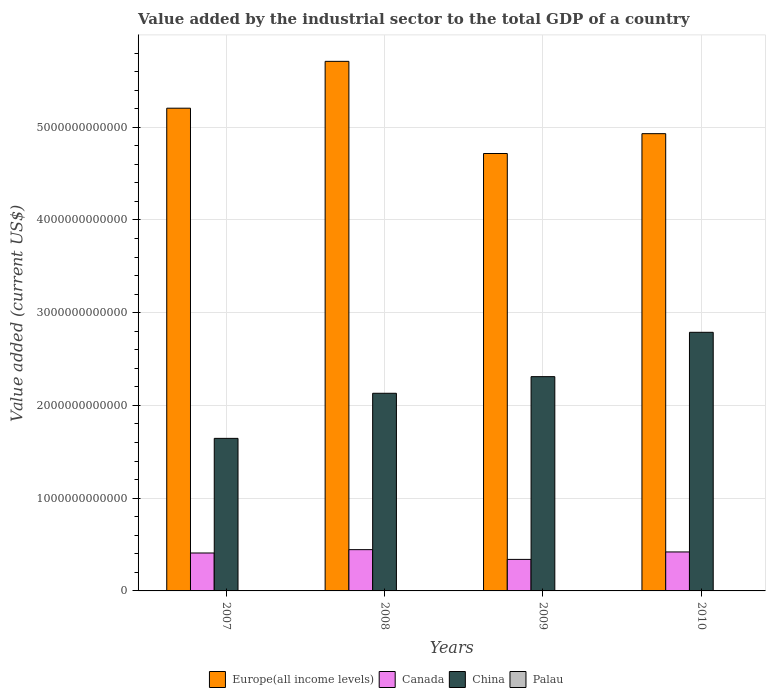How many different coloured bars are there?
Provide a short and direct response. 4. How many groups of bars are there?
Provide a short and direct response. 4. Are the number of bars per tick equal to the number of legend labels?
Provide a short and direct response. Yes. Are the number of bars on each tick of the X-axis equal?
Provide a short and direct response. Yes. How many bars are there on the 2nd tick from the left?
Give a very brief answer. 4. What is the label of the 2nd group of bars from the left?
Your answer should be compact. 2008. In how many cases, is the number of bars for a given year not equal to the number of legend labels?
Ensure brevity in your answer.  0. What is the value added by the industrial sector to the total GDP in China in 2009?
Your answer should be very brief. 2.31e+12. Across all years, what is the maximum value added by the industrial sector to the total GDP in Canada?
Make the answer very short. 4.45e+11. Across all years, what is the minimum value added by the industrial sector to the total GDP in China?
Make the answer very short. 1.65e+12. What is the total value added by the industrial sector to the total GDP in Palau in the graph?
Provide a succinct answer. 7.32e+07. What is the difference between the value added by the industrial sector to the total GDP in Europe(all income levels) in 2007 and that in 2010?
Provide a short and direct response. 2.75e+11. What is the difference between the value added by the industrial sector to the total GDP in Canada in 2010 and the value added by the industrial sector to the total GDP in Palau in 2009?
Give a very brief answer. 4.20e+11. What is the average value added by the industrial sector to the total GDP in Europe(all income levels) per year?
Your answer should be compact. 5.14e+12. In the year 2008, what is the difference between the value added by the industrial sector to the total GDP in China and value added by the industrial sector to the total GDP in Europe(all income levels)?
Your answer should be very brief. -3.58e+12. In how many years, is the value added by the industrial sector to the total GDP in Canada greater than 4600000000000 US$?
Offer a very short reply. 0. What is the ratio of the value added by the industrial sector to the total GDP in Europe(all income levels) in 2007 to that in 2009?
Give a very brief answer. 1.1. Is the difference between the value added by the industrial sector to the total GDP in China in 2007 and 2009 greater than the difference between the value added by the industrial sector to the total GDP in Europe(all income levels) in 2007 and 2009?
Your answer should be compact. No. What is the difference between the highest and the second highest value added by the industrial sector to the total GDP in Europe(all income levels)?
Your answer should be compact. 5.05e+11. What is the difference between the highest and the lowest value added by the industrial sector to the total GDP in Europe(all income levels)?
Make the answer very short. 9.94e+11. Is it the case that in every year, the sum of the value added by the industrial sector to the total GDP in China and value added by the industrial sector to the total GDP in Canada is greater than the sum of value added by the industrial sector to the total GDP in Europe(all income levels) and value added by the industrial sector to the total GDP in Palau?
Offer a terse response. No. What does the 2nd bar from the left in 2007 represents?
Offer a terse response. Canada. What does the 3rd bar from the right in 2007 represents?
Give a very brief answer. Canada. Is it the case that in every year, the sum of the value added by the industrial sector to the total GDP in Europe(all income levels) and value added by the industrial sector to the total GDP in Canada is greater than the value added by the industrial sector to the total GDP in China?
Provide a succinct answer. Yes. Are all the bars in the graph horizontal?
Your answer should be compact. No. What is the difference between two consecutive major ticks on the Y-axis?
Your answer should be very brief. 1.00e+12. Does the graph contain any zero values?
Offer a terse response. No. Does the graph contain grids?
Provide a succinct answer. Yes. How many legend labels are there?
Your response must be concise. 4. What is the title of the graph?
Keep it short and to the point. Value added by the industrial sector to the total GDP of a country. What is the label or title of the Y-axis?
Offer a terse response. Value added (current US$). What is the Value added (current US$) in Europe(all income levels) in 2007?
Offer a very short reply. 5.21e+12. What is the Value added (current US$) in Canada in 2007?
Offer a very short reply. 4.09e+11. What is the Value added (current US$) in China in 2007?
Provide a short and direct response. 1.65e+12. What is the Value added (current US$) of Palau in 2007?
Give a very brief answer. 2.17e+07. What is the Value added (current US$) in Europe(all income levels) in 2008?
Make the answer very short. 5.71e+12. What is the Value added (current US$) of Canada in 2008?
Provide a succinct answer. 4.45e+11. What is the Value added (current US$) in China in 2008?
Your answer should be compact. 2.13e+12. What is the Value added (current US$) of Palau in 2008?
Your response must be concise. 1.67e+07. What is the Value added (current US$) of Europe(all income levels) in 2009?
Make the answer very short. 4.72e+12. What is the Value added (current US$) of Canada in 2009?
Give a very brief answer. 3.40e+11. What is the Value added (current US$) in China in 2009?
Your answer should be compact. 2.31e+12. What is the Value added (current US$) in Palau in 2009?
Your answer should be compact. 1.66e+07. What is the Value added (current US$) of Europe(all income levels) in 2010?
Offer a very short reply. 4.93e+12. What is the Value added (current US$) of Canada in 2010?
Ensure brevity in your answer.  4.20e+11. What is the Value added (current US$) in China in 2010?
Your answer should be compact. 2.79e+12. What is the Value added (current US$) of Palau in 2010?
Give a very brief answer. 1.82e+07. Across all years, what is the maximum Value added (current US$) of Europe(all income levels)?
Ensure brevity in your answer.  5.71e+12. Across all years, what is the maximum Value added (current US$) in Canada?
Give a very brief answer. 4.45e+11. Across all years, what is the maximum Value added (current US$) of China?
Your answer should be compact. 2.79e+12. Across all years, what is the maximum Value added (current US$) in Palau?
Your answer should be very brief. 2.17e+07. Across all years, what is the minimum Value added (current US$) of Europe(all income levels)?
Provide a short and direct response. 4.72e+12. Across all years, what is the minimum Value added (current US$) of Canada?
Make the answer very short. 3.40e+11. Across all years, what is the minimum Value added (current US$) in China?
Offer a very short reply. 1.65e+12. Across all years, what is the minimum Value added (current US$) of Palau?
Keep it short and to the point. 1.66e+07. What is the total Value added (current US$) in Europe(all income levels) in the graph?
Ensure brevity in your answer.  2.06e+13. What is the total Value added (current US$) in Canada in the graph?
Make the answer very short. 1.61e+12. What is the total Value added (current US$) of China in the graph?
Your answer should be compact. 8.88e+12. What is the total Value added (current US$) of Palau in the graph?
Offer a very short reply. 7.32e+07. What is the difference between the Value added (current US$) in Europe(all income levels) in 2007 and that in 2008?
Keep it short and to the point. -5.05e+11. What is the difference between the Value added (current US$) in Canada in 2007 and that in 2008?
Make the answer very short. -3.60e+1. What is the difference between the Value added (current US$) of China in 2007 and that in 2008?
Your answer should be compact. -4.86e+11. What is the difference between the Value added (current US$) in Palau in 2007 and that in 2008?
Keep it short and to the point. 5.05e+06. What is the difference between the Value added (current US$) in Europe(all income levels) in 2007 and that in 2009?
Provide a short and direct response. 4.89e+11. What is the difference between the Value added (current US$) in Canada in 2007 and that in 2009?
Offer a terse response. 6.92e+1. What is the difference between the Value added (current US$) of China in 2007 and that in 2009?
Provide a short and direct response. -6.66e+11. What is the difference between the Value added (current US$) in Palau in 2007 and that in 2009?
Your answer should be compact. 5.14e+06. What is the difference between the Value added (current US$) of Europe(all income levels) in 2007 and that in 2010?
Your answer should be very brief. 2.75e+11. What is the difference between the Value added (current US$) in Canada in 2007 and that in 2010?
Your answer should be compact. -1.13e+1. What is the difference between the Value added (current US$) of China in 2007 and that in 2010?
Offer a very short reply. -1.14e+12. What is the difference between the Value added (current US$) in Palau in 2007 and that in 2010?
Your answer should be compact. 3.50e+06. What is the difference between the Value added (current US$) of Europe(all income levels) in 2008 and that in 2009?
Your answer should be compact. 9.94e+11. What is the difference between the Value added (current US$) in Canada in 2008 and that in 2009?
Offer a very short reply. 1.05e+11. What is the difference between the Value added (current US$) of China in 2008 and that in 2009?
Offer a very short reply. -1.79e+11. What is the difference between the Value added (current US$) in Palau in 2008 and that in 2009?
Give a very brief answer. 8.72e+04. What is the difference between the Value added (current US$) of Europe(all income levels) in 2008 and that in 2010?
Keep it short and to the point. 7.80e+11. What is the difference between the Value added (current US$) of Canada in 2008 and that in 2010?
Make the answer very short. 2.47e+1. What is the difference between the Value added (current US$) in China in 2008 and that in 2010?
Make the answer very short. -6.57e+11. What is the difference between the Value added (current US$) in Palau in 2008 and that in 2010?
Keep it short and to the point. -1.55e+06. What is the difference between the Value added (current US$) of Europe(all income levels) in 2009 and that in 2010?
Your answer should be very brief. -2.14e+11. What is the difference between the Value added (current US$) of Canada in 2009 and that in 2010?
Keep it short and to the point. -8.05e+1. What is the difference between the Value added (current US$) of China in 2009 and that in 2010?
Make the answer very short. -4.78e+11. What is the difference between the Value added (current US$) in Palau in 2009 and that in 2010?
Offer a terse response. -1.64e+06. What is the difference between the Value added (current US$) of Europe(all income levels) in 2007 and the Value added (current US$) of Canada in 2008?
Your response must be concise. 4.76e+12. What is the difference between the Value added (current US$) of Europe(all income levels) in 2007 and the Value added (current US$) of China in 2008?
Your response must be concise. 3.07e+12. What is the difference between the Value added (current US$) in Europe(all income levels) in 2007 and the Value added (current US$) in Palau in 2008?
Keep it short and to the point. 5.21e+12. What is the difference between the Value added (current US$) of Canada in 2007 and the Value added (current US$) of China in 2008?
Offer a terse response. -1.72e+12. What is the difference between the Value added (current US$) in Canada in 2007 and the Value added (current US$) in Palau in 2008?
Give a very brief answer. 4.09e+11. What is the difference between the Value added (current US$) of China in 2007 and the Value added (current US$) of Palau in 2008?
Your response must be concise. 1.65e+12. What is the difference between the Value added (current US$) of Europe(all income levels) in 2007 and the Value added (current US$) of Canada in 2009?
Offer a very short reply. 4.87e+12. What is the difference between the Value added (current US$) of Europe(all income levels) in 2007 and the Value added (current US$) of China in 2009?
Your response must be concise. 2.89e+12. What is the difference between the Value added (current US$) of Europe(all income levels) in 2007 and the Value added (current US$) of Palau in 2009?
Your answer should be very brief. 5.21e+12. What is the difference between the Value added (current US$) in Canada in 2007 and the Value added (current US$) in China in 2009?
Give a very brief answer. -1.90e+12. What is the difference between the Value added (current US$) of Canada in 2007 and the Value added (current US$) of Palau in 2009?
Make the answer very short. 4.09e+11. What is the difference between the Value added (current US$) in China in 2007 and the Value added (current US$) in Palau in 2009?
Provide a succinct answer. 1.65e+12. What is the difference between the Value added (current US$) in Europe(all income levels) in 2007 and the Value added (current US$) in Canada in 2010?
Offer a terse response. 4.79e+12. What is the difference between the Value added (current US$) of Europe(all income levels) in 2007 and the Value added (current US$) of China in 2010?
Offer a very short reply. 2.42e+12. What is the difference between the Value added (current US$) of Europe(all income levels) in 2007 and the Value added (current US$) of Palau in 2010?
Your answer should be very brief. 5.21e+12. What is the difference between the Value added (current US$) of Canada in 2007 and the Value added (current US$) of China in 2010?
Provide a short and direct response. -2.38e+12. What is the difference between the Value added (current US$) in Canada in 2007 and the Value added (current US$) in Palau in 2010?
Keep it short and to the point. 4.09e+11. What is the difference between the Value added (current US$) in China in 2007 and the Value added (current US$) in Palau in 2010?
Your answer should be compact. 1.65e+12. What is the difference between the Value added (current US$) of Europe(all income levels) in 2008 and the Value added (current US$) of Canada in 2009?
Provide a short and direct response. 5.37e+12. What is the difference between the Value added (current US$) in Europe(all income levels) in 2008 and the Value added (current US$) in China in 2009?
Provide a short and direct response. 3.40e+12. What is the difference between the Value added (current US$) of Europe(all income levels) in 2008 and the Value added (current US$) of Palau in 2009?
Give a very brief answer. 5.71e+12. What is the difference between the Value added (current US$) of Canada in 2008 and the Value added (current US$) of China in 2009?
Provide a short and direct response. -1.87e+12. What is the difference between the Value added (current US$) of Canada in 2008 and the Value added (current US$) of Palau in 2009?
Give a very brief answer. 4.45e+11. What is the difference between the Value added (current US$) of China in 2008 and the Value added (current US$) of Palau in 2009?
Provide a short and direct response. 2.13e+12. What is the difference between the Value added (current US$) in Europe(all income levels) in 2008 and the Value added (current US$) in Canada in 2010?
Your answer should be compact. 5.29e+12. What is the difference between the Value added (current US$) of Europe(all income levels) in 2008 and the Value added (current US$) of China in 2010?
Your response must be concise. 2.92e+12. What is the difference between the Value added (current US$) in Europe(all income levels) in 2008 and the Value added (current US$) in Palau in 2010?
Provide a short and direct response. 5.71e+12. What is the difference between the Value added (current US$) of Canada in 2008 and the Value added (current US$) of China in 2010?
Offer a terse response. -2.34e+12. What is the difference between the Value added (current US$) in Canada in 2008 and the Value added (current US$) in Palau in 2010?
Make the answer very short. 4.45e+11. What is the difference between the Value added (current US$) in China in 2008 and the Value added (current US$) in Palau in 2010?
Keep it short and to the point. 2.13e+12. What is the difference between the Value added (current US$) in Europe(all income levels) in 2009 and the Value added (current US$) in Canada in 2010?
Offer a very short reply. 4.30e+12. What is the difference between the Value added (current US$) of Europe(all income levels) in 2009 and the Value added (current US$) of China in 2010?
Offer a very short reply. 1.93e+12. What is the difference between the Value added (current US$) in Europe(all income levels) in 2009 and the Value added (current US$) in Palau in 2010?
Ensure brevity in your answer.  4.72e+12. What is the difference between the Value added (current US$) in Canada in 2009 and the Value added (current US$) in China in 2010?
Offer a very short reply. -2.45e+12. What is the difference between the Value added (current US$) of Canada in 2009 and the Value added (current US$) of Palau in 2010?
Your answer should be compact. 3.40e+11. What is the difference between the Value added (current US$) in China in 2009 and the Value added (current US$) in Palau in 2010?
Offer a terse response. 2.31e+12. What is the average Value added (current US$) in Europe(all income levels) per year?
Provide a short and direct response. 5.14e+12. What is the average Value added (current US$) in Canada per year?
Ensure brevity in your answer.  4.04e+11. What is the average Value added (current US$) of China per year?
Provide a short and direct response. 2.22e+12. What is the average Value added (current US$) in Palau per year?
Offer a terse response. 1.83e+07. In the year 2007, what is the difference between the Value added (current US$) of Europe(all income levels) and Value added (current US$) of Canada?
Keep it short and to the point. 4.80e+12. In the year 2007, what is the difference between the Value added (current US$) of Europe(all income levels) and Value added (current US$) of China?
Your answer should be compact. 3.56e+12. In the year 2007, what is the difference between the Value added (current US$) of Europe(all income levels) and Value added (current US$) of Palau?
Your answer should be compact. 5.21e+12. In the year 2007, what is the difference between the Value added (current US$) of Canada and Value added (current US$) of China?
Keep it short and to the point. -1.24e+12. In the year 2007, what is the difference between the Value added (current US$) of Canada and Value added (current US$) of Palau?
Provide a short and direct response. 4.09e+11. In the year 2007, what is the difference between the Value added (current US$) of China and Value added (current US$) of Palau?
Ensure brevity in your answer.  1.65e+12. In the year 2008, what is the difference between the Value added (current US$) in Europe(all income levels) and Value added (current US$) in Canada?
Offer a very short reply. 5.27e+12. In the year 2008, what is the difference between the Value added (current US$) in Europe(all income levels) and Value added (current US$) in China?
Provide a short and direct response. 3.58e+12. In the year 2008, what is the difference between the Value added (current US$) in Europe(all income levels) and Value added (current US$) in Palau?
Ensure brevity in your answer.  5.71e+12. In the year 2008, what is the difference between the Value added (current US$) in Canada and Value added (current US$) in China?
Your response must be concise. -1.69e+12. In the year 2008, what is the difference between the Value added (current US$) in Canada and Value added (current US$) in Palau?
Your response must be concise. 4.45e+11. In the year 2008, what is the difference between the Value added (current US$) of China and Value added (current US$) of Palau?
Your answer should be compact. 2.13e+12. In the year 2009, what is the difference between the Value added (current US$) of Europe(all income levels) and Value added (current US$) of Canada?
Ensure brevity in your answer.  4.38e+12. In the year 2009, what is the difference between the Value added (current US$) of Europe(all income levels) and Value added (current US$) of China?
Your answer should be very brief. 2.41e+12. In the year 2009, what is the difference between the Value added (current US$) in Europe(all income levels) and Value added (current US$) in Palau?
Provide a succinct answer. 4.72e+12. In the year 2009, what is the difference between the Value added (current US$) of Canada and Value added (current US$) of China?
Keep it short and to the point. -1.97e+12. In the year 2009, what is the difference between the Value added (current US$) in Canada and Value added (current US$) in Palau?
Offer a terse response. 3.40e+11. In the year 2009, what is the difference between the Value added (current US$) of China and Value added (current US$) of Palau?
Give a very brief answer. 2.31e+12. In the year 2010, what is the difference between the Value added (current US$) in Europe(all income levels) and Value added (current US$) in Canada?
Give a very brief answer. 4.51e+12. In the year 2010, what is the difference between the Value added (current US$) in Europe(all income levels) and Value added (current US$) in China?
Your answer should be very brief. 2.14e+12. In the year 2010, what is the difference between the Value added (current US$) of Europe(all income levels) and Value added (current US$) of Palau?
Make the answer very short. 4.93e+12. In the year 2010, what is the difference between the Value added (current US$) in Canada and Value added (current US$) in China?
Offer a terse response. -2.37e+12. In the year 2010, what is the difference between the Value added (current US$) in Canada and Value added (current US$) in Palau?
Ensure brevity in your answer.  4.20e+11. In the year 2010, what is the difference between the Value added (current US$) in China and Value added (current US$) in Palau?
Provide a short and direct response. 2.79e+12. What is the ratio of the Value added (current US$) in Europe(all income levels) in 2007 to that in 2008?
Offer a terse response. 0.91. What is the ratio of the Value added (current US$) in Canada in 2007 to that in 2008?
Your answer should be compact. 0.92. What is the ratio of the Value added (current US$) in China in 2007 to that in 2008?
Keep it short and to the point. 0.77. What is the ratio of the Value added (current US$) in Palau in 2007 to that in 2008?
Your answer should be compact. 1.3. What is the ratio of the Value added (current US$) in Europe(all income levels) in 2007 to that in 2009?
Offer a terse response. 1.1. What is the ratio of the Value added (current US$) in Canada in 2007 to that in 2009?
Provide a succinct answer. 1.2. What is the ratio of the Value added (current US$) of China in 2007 to that in 2009?
Make the answer very short. 0.71. What is the ratio of the Value added (current US$) of Palau in 2007 to that in 2009?
Keep it short and to the point. 1.31. What is the ratio of the Value added (current US$) in Europe(all income levels) in 2007 to that in 2010?
Give a very brief answer. 1.06. What is the ratio of the Value added (current US$) in Canada in 2007 to that in 2010?
Give a very brief answer. 0.97. What is the ratio of the Value added (current US$) of China in 2007 to that in 2010?
Make the answer very short. 0.59. What is the ratio of the Value added (current US$) of Palau in 2007 to that in 2010?
Your answer should be compact. 1.19. What is the ratio of the Value added (current US$) of Europe(all income levels) in 2008 to that in 2009?
Offer a very short reply. 1.21. What is the ratio of the Value added (current US$) of Canada in 2008 to that in 2009?
Ensure brevity in your answer.  1.31. What is the ratio of the Value added (current US$) in China in 2008 to that in 2009?
Offer a very short reply. 0.92. What is the ratio of the Value added (current US$) in Palau in 2008 to that in 2009?
Offer a terse response. 1.01. What is the ratio of the Value added (current US$) of Europe(all income levels) in 2008 to that in 2010?
Give a very brief answer. 1.16. What is the ratio of the Value added (current US$) of Canada in 2008 to that in 2010?
Your answer should be very brief. 1.06. What is the ratio of the Value added (current US$) of China in 2008 to that in 2010?
Make the answer very short. 0.76. What is the ratio of the Value added (current US$) of Palau in 2008 to that in 2010?
Provide a short and direct response. 0.91. What is the ratio of the Value added (current US$) in Europe(all income levels) in 2009 to that in 2010?
Give a very brief answer. 0.96. What is the ratio of the Value added (current US$) in Canada in 2009 to that in 2010?
Your response must be concise. 0.81. What is the ratio of the Value added (current US$) in China in 2009 to that in 2010?
Make the answer very short. 0.83. What is the ratio of the Value added (current US$) of Palau in 2009 to that in 2010?
Keep it short and to the point. 0.91. What is the difference between the highest and the second highest Value added (current US$) in Europe(all income levels)?
Give a very brief answer. 5.05e+11. What is the difference between the highest and the second highest Value added (current US$) in Canada?
Your answer should be compact. 2.47e+1. What is the difference between the highest and the second highest Value added (current US$) in China?
Offer a very short reply. 4.78e+11. What is the difference between the highest and the second highest Value added (current US$) in Palau?
Keep it short and to the point. 3.50e+06. What is the difference between the highest and the lowest Value added (current US$) in Europe(all income levels)?
Make the answer very short. 9.94e+11. What is the difference between the highest and the lowest Value added (current US$) in Canada?
Your answer should be compact. 1.05e+11. What is the difference between the highest and the lowest Value added (current US$) of China?
Offer a terse response. 1.14e+12. What is the difference between the highest and the lowest Value added (current US$) in Palau?
Ensure brevity in your answer.  5.14e+06. 